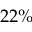Convert formula to latex. <formula><loc_0><loc_0><loc_500><loc_500>2 2 \%</formula> 